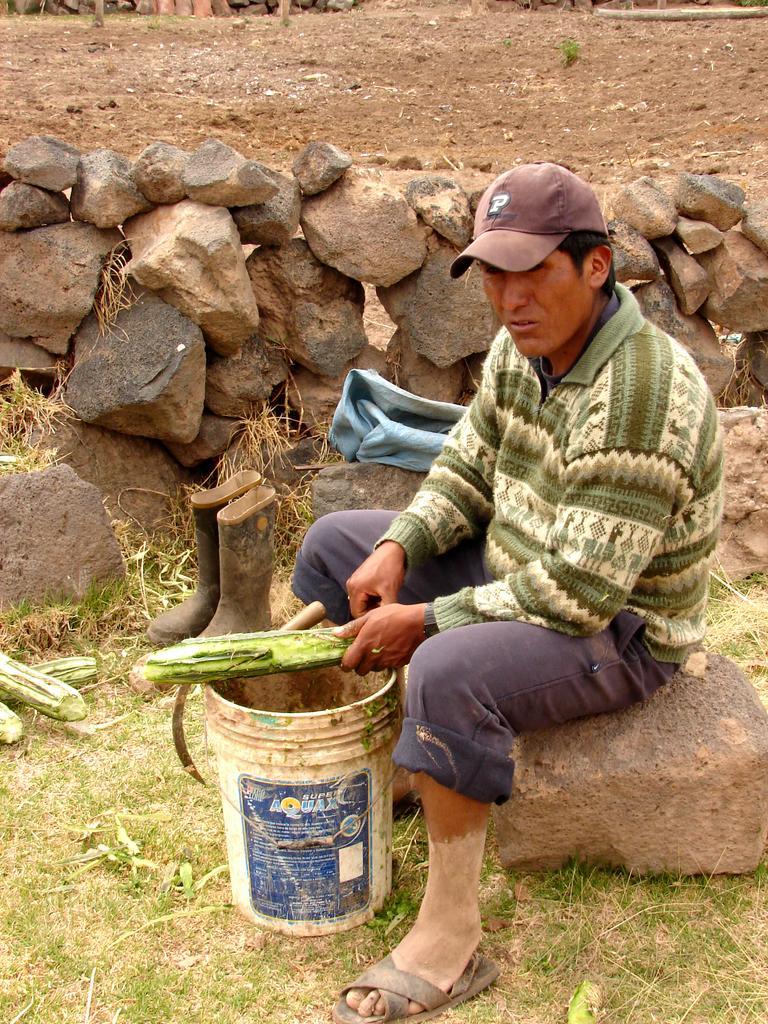Could you give a brief overview of what you see in this image? In the background we can see the ground and the stone wall. In this picture we can see a man, wearing a cap. He is sitting on the rock which is placed on the grass. We can see a vegetable in his hand. We can also see a bucket, knife, vegetables. Beside him we can see the boots and a blue cloth. 